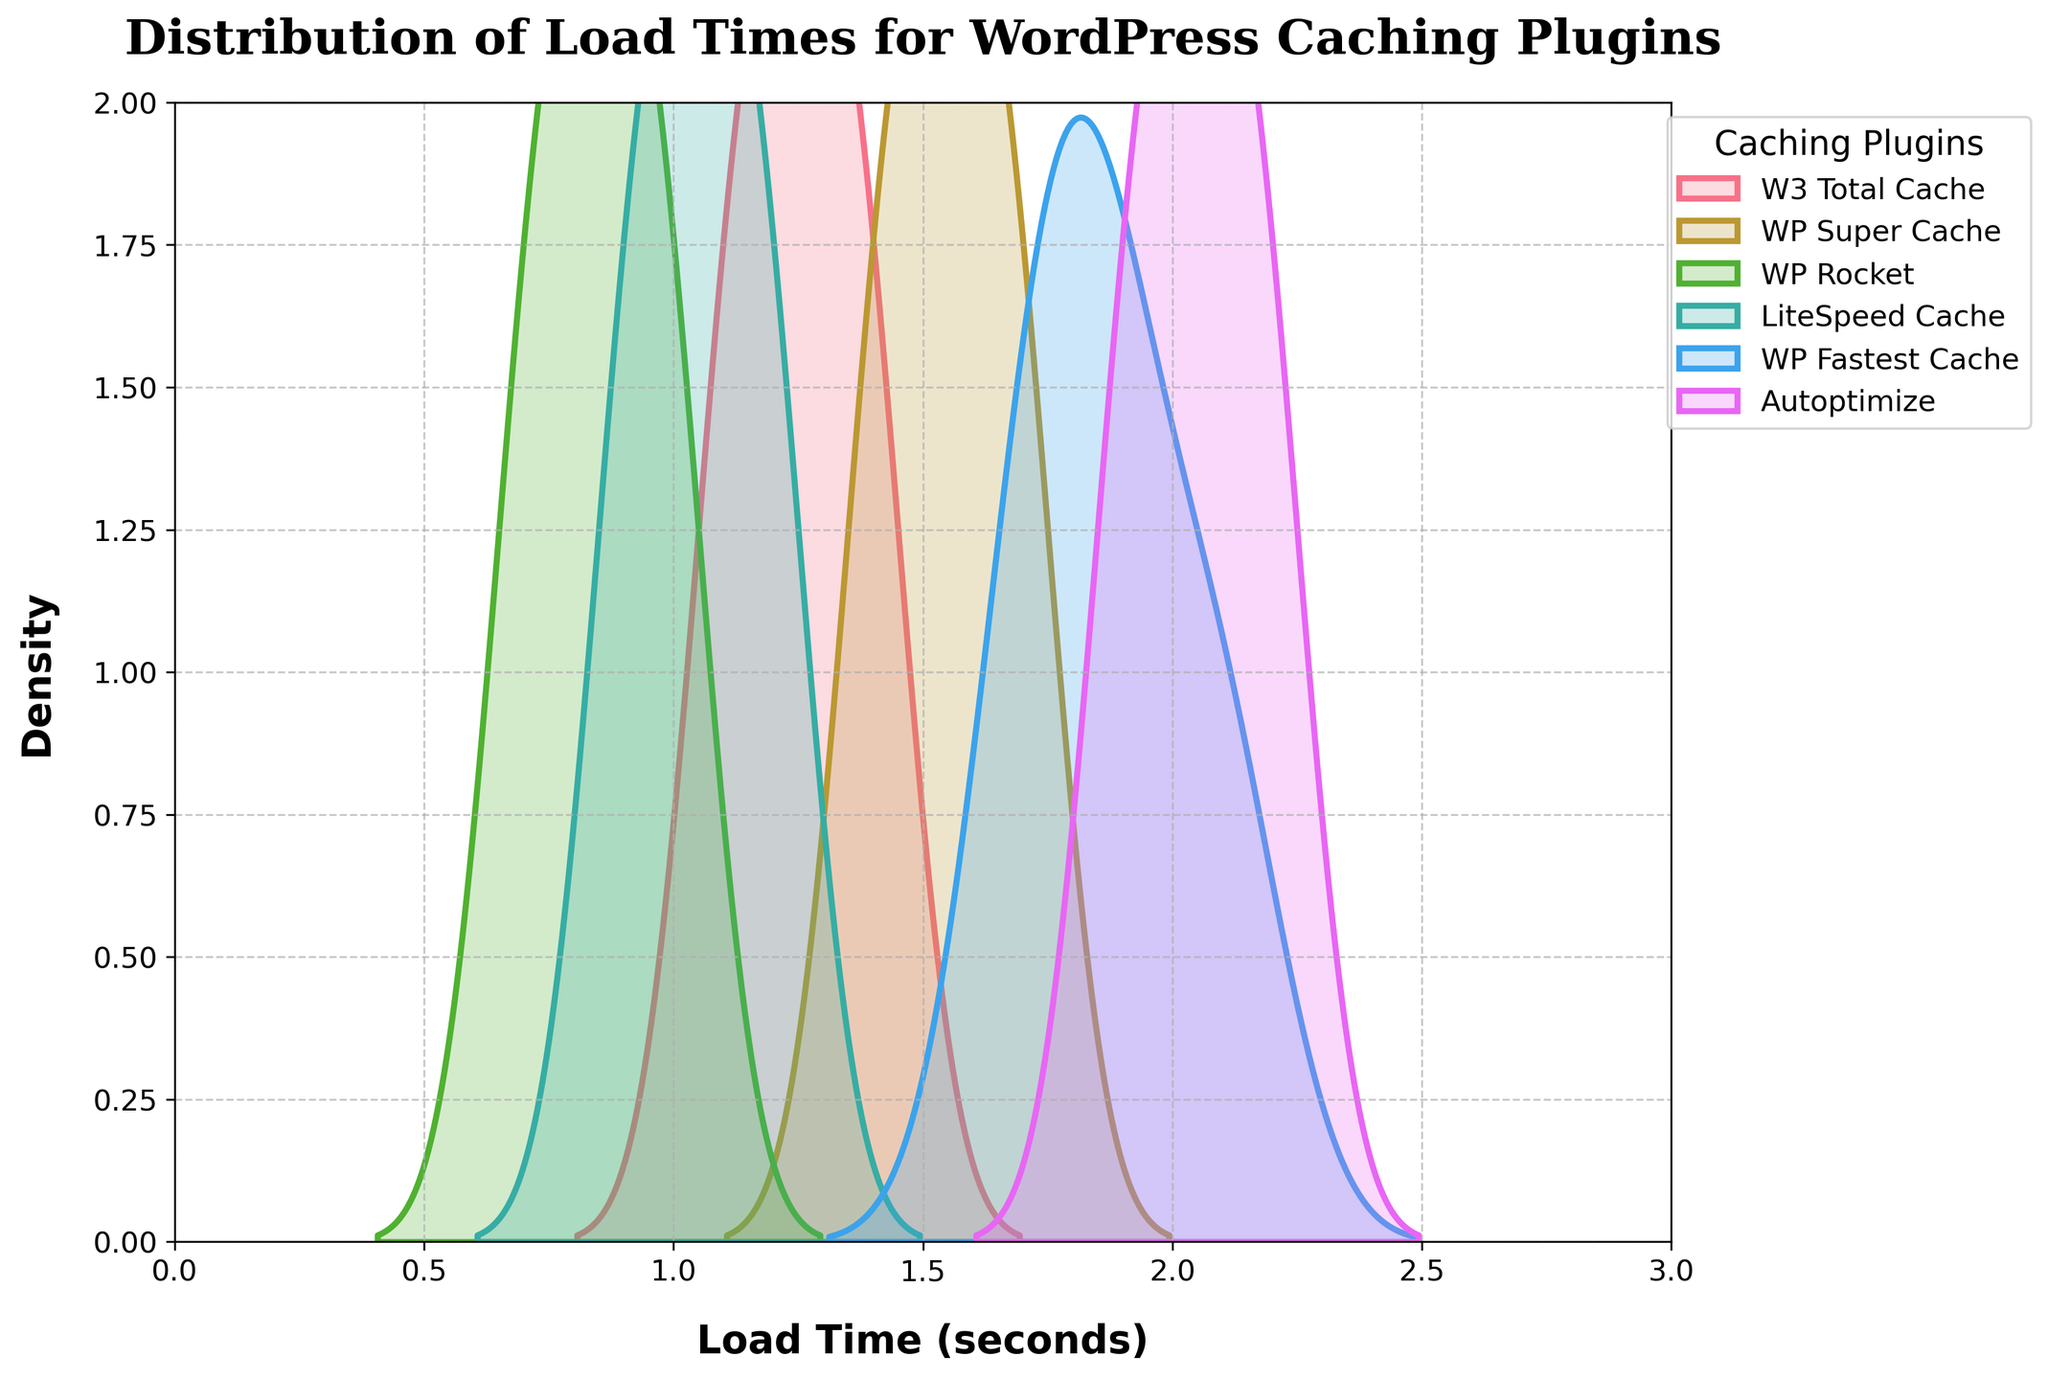What is the title of the density plot? The title is usually found at the top of the density plot with bold, large font size for better visibility.
Answer: Distribution of Load Times for WordPress Caching Plugins What are the units used for the x-axis? The x-axis typically represents the load times of WordPress sites using various caching plugins, measured in seconds. This unit is usually specified in the axis label.
Answer: seconds Which plugin has the lowest peak density in load time? Identify the curve with the smallest peak height on the y-axis. Each curve is labeled with a different plugin name.
Answer: Autoptimize Which plugin has the highest peak density in load time? Identify the curve with the highest peak height on the y-axis. Each curve is labeled with a different plugin name.
Answer: WP Rocket What range of load times does the WP Rocket plugin cover? Look for the leftmost and rightmost points where the WP Rocket's density curve appears above the x-axis.
Answer: 0.7 to 1.0 seconds Between WP Super Cache and LiteSpeed Cache, which one has a lower average load time? Compare the positions of their peaks and the spread of their density curves. The first one appears to the left of the other (in most places) indicates a lower average load time.
Answer: LiteSpeed Cache Which plugin has the most spread-out distribution of load times? Observe which density curve spans the widest range on the x-axis. A more spread-out curve indicates more variability in load times.
Answer: Autoptimize How do the peaks compare between WP Fastest Cache and W3 Total Cache? Compare the heights of the density curves labeled WP Fastest Cache and W3 Total Cache to see which peaks higher.
Answer: WP Fastest Cache peaks higher than W3 Total Cache Is there any overlap in the density curves of LiteSpeed Cache and WP Rocket? Check if the density curves for LiteSpeed Cache and WP Rocket overlap in any region on the x-axis.
Answer: Yes Are there any plugins whose density curves do not overlap at all? Observe if there are any pairs of density curves that do not share any common region on the x-axis.
Answer: No 